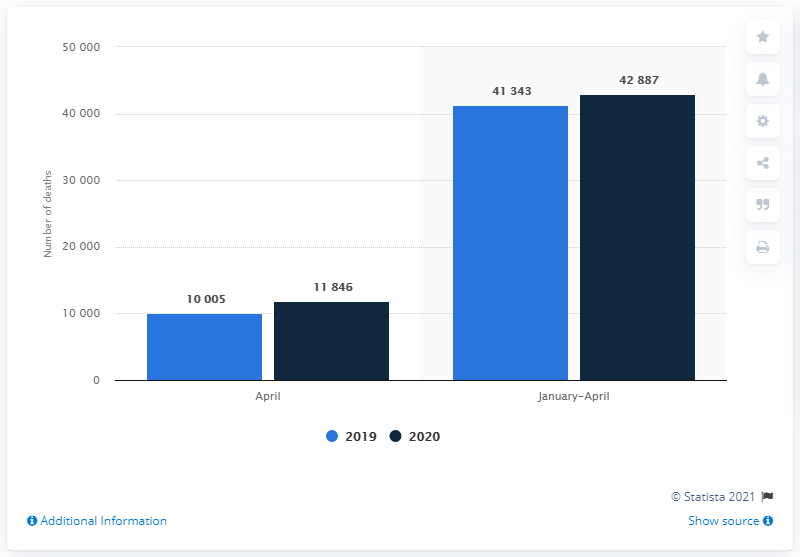Give some essential details in this illustration. In 2020, a total of 3,104 deaths occurred between January and March. In April 2020, there were 11846 deaths. In April 2020, a total of 11,846 death certificates were issued. 